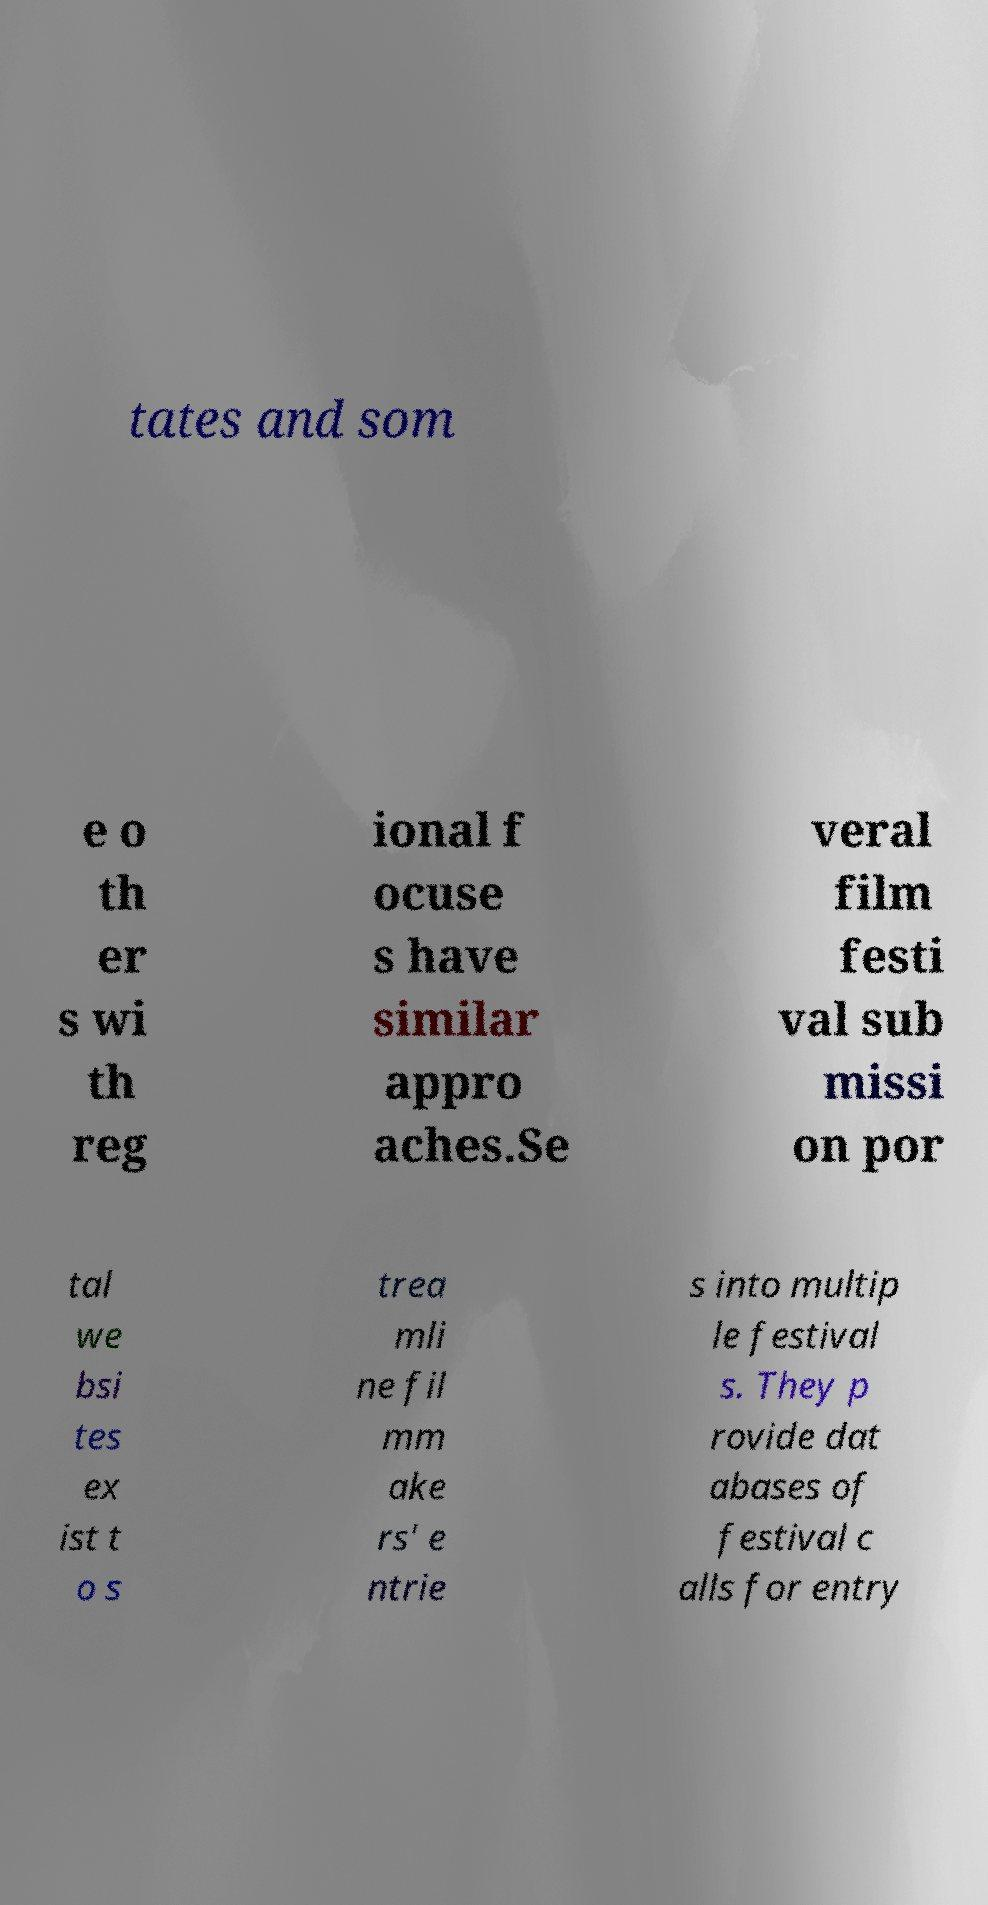What messages or text are displayed in this image? I need them in a readable, typed format. tates and som e o th er s wi th reg ional f ocuse s have similar appro aches.Se veral film festi val sub missi on por tal we bsi tes ex ist t o s trea mli ne fil mm ake rs' e ntrie s into multip le festival s. They p rovide dat abases of festival c alls for entry 